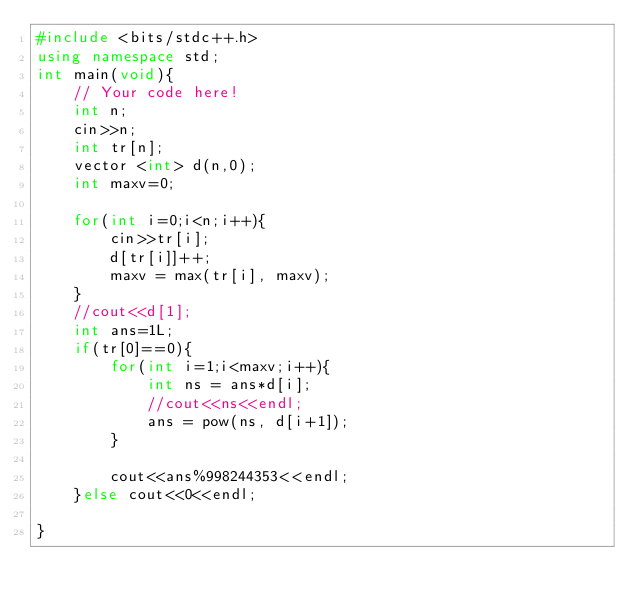Convert code to text. <code><loc_0><loc_0><loc_500><loc_500><_C++_>#include <bits/stdc++.h>
using namespace std;
int main(void){
    // Your code here!
    int n;
    cin>>n;
    int tr[n];
    vector <int> d(n,0);
    int maxv=0;
    
    for(int i=0;i<n;i++){
        cin>>tr[i];
        d[tr[i]]++;
        maxv = max(tr[i], maxv);
    }
    //cout<<d[1];
    int ans=1L;
    if(tr[0]==0){
        for(int i=1;i<maxv;i++){
            int ns = ans*d[i];
            //cout<<ns<<endl;
            ans = pow(ns, d[i+1]);
        }
        
        cout<<ans%998244353<<endl;
    }else cout<<0<<endl;
    
}</code> 